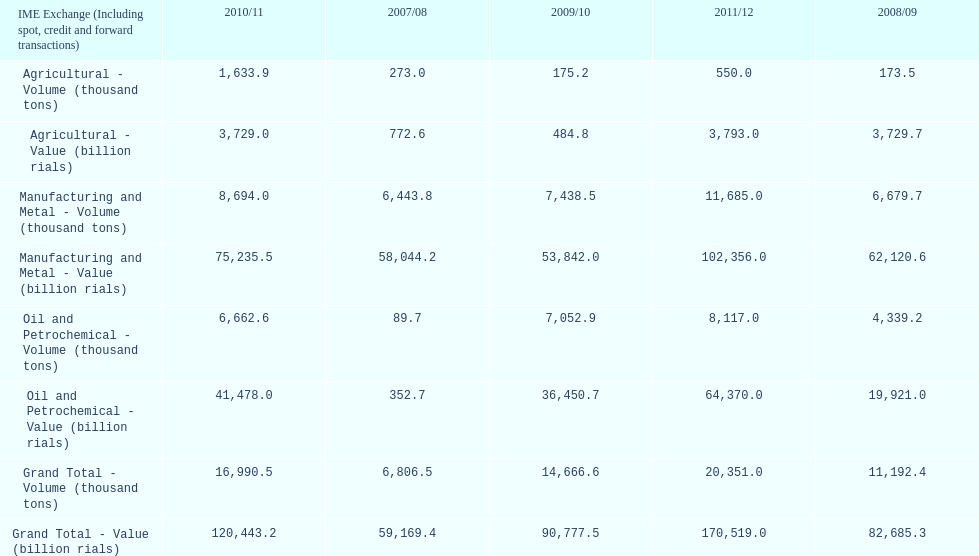What year saw the greatest value for manufacturing and metal in iran? 2011/12. 